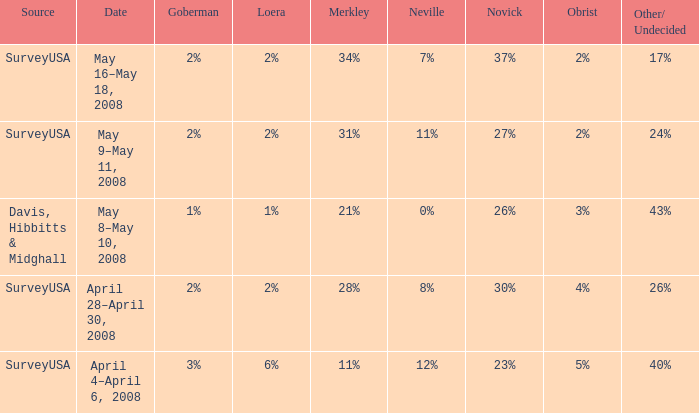In which neville's case is the novick rate 23%? 12%. 